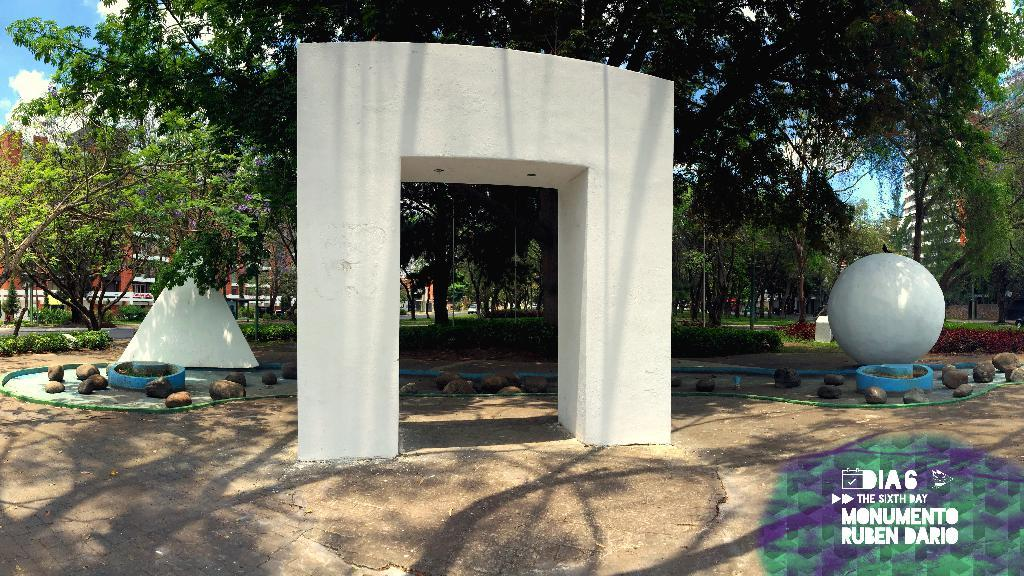What type of natural elements can be seen in the image? There are trees in the image. What objects are located in the middle of the image? There are stones in the middle of the image. Where is the watermark placed in the image? The watermark is in the bottom right side of the image. What is visible in the background of the image? There is sky visible in the background of the image. What company's logo can be seen in the image? There is no company logo present in the image. Is there a flame visible in the image? No, there is no flame visible in the image. 